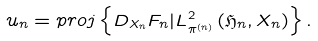<formula> <loc_0><loc_0><loc_500><loc_500>u _ { n } = p r o j \left \{ D _ { X _ { n } } F _ { n } | L _ { \pi ^ { \left ( n \right ) } } ^ { 2 } \left ( \mathfrak { H } _ { n } , X _ { n } \right ) \right \} .</formula> 